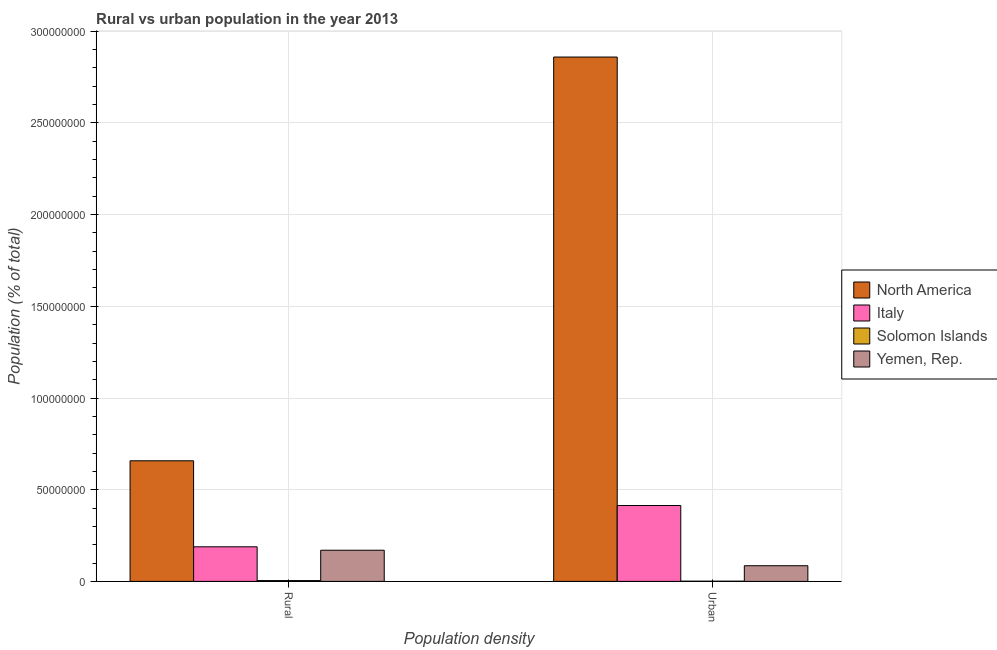How many different coloured bars are there?
Your response must be concise. 4. Are the number of bars per tick equal to the number of legend labels?
Offer a terse response. Yes. What is the label of the 1st group of bars from the left?
Your answer should be compact. Rural. What is the rural population density in Solomon Islands?
Give a very brief answer. 4.41e+05. Across all countries, what is the maximum urban population density?
Offer a terse response. 2.86e+08. Across all countries, what is the minimum urban population density?
Offer a very short reply. 1.20e+05. In which country was the urban population density maximum?
Provide a succinct answer. North America. In which country was the rural population density minimum?
Ensure brevity in your answer.  Solomon Islands. What is the total rural population density in the graph?
Offer a terse response. 1.02e+08. What is the difference between the urban population density in Italy and that in North America?
Keep it short and to the point. -2.45e+08. What is the difference between the rural population density in Solomon Islands and the urban population density in Yemen, Rep.?
Your answer should be very brief. -8.10e+06. What is the average urban population density per country?
Provide a succinct answer. 8.40e+07. What is the difference between the rural population density and urban population density in Yemen, Rep.?
Your answer should be compact. 8.45e+06. In how many countries, is the rural population density greater than 60000000 %?
Your answer should be compact. 1. What is the ratio of the rural population density in Italy to that in Solomon Islands?
Your answer should be compact. 42.81. In how many countries, is the urban population density greater than the average urban population density taken over all countries?
Give a very brief answer. 1. What does the 2nd bar from the left in Rural represents?
Your response must be concise. Italy. How many bars are there?
Give a very brief answer. 8. Are the values on the major ticks of Y-axis written in scientific E-notation?
Give a very brief answer. No. Does the graph contain any zero values?
Ensure brevity in your answer.  No. Where does the legend appear in the graph?
Keep it short and to the point. Center right. What is the title of the graph?
Ensure brevity in your answer.  Rural vs urban population in the year 2013. Does "United Arab Emirates" appear as one of the legend labels in the graph?
Your answer should be very brief. No. What is the label or title of the X-axis?
Your answer should be very brief. Population density. What is the label or title of the Y-axis?
Offer a terse response. Population (% of total). What is the Population (% of total) of North America in Rural?
Keep it short and to the point. 6.58e+07. What is the Population (% of total) in Italy in Rural?
Provide a succinct answer. 1.89e+07. What is the Population (% of total) of Solomon Islands in Rural?
Your answer should be very brief. 4.41e+05. What is the Population (% of total) of Yemen, Rep. in Rural?
Your response must be concise. 1.70e+07. What is the Population (% of total) of North America in Urban?
Offer a terse response. 2.86e+08. What is the Population (% of total) of Italy in Urban?
Make the answer very short. 4.14e+07. What is the Population (% of total) of Solomon Islands in Urban?
Ensure brevity in your answer.  1.20e+05. What is the Population (% of total) of Yemen, Rep. in Urban?
Make the answer very short. 8.54e+06. Across all Population density, what is the maximum Population (% of total) in North America?
Keep it short and to the point. 2.86e+08. Across all Population density, what is the maximum Population (% of total) of Italy?
Give a very brief answer. 4.14e+07. Across all Population density, what is the maximum Population (% of total) in Solomon Islands?
Your answer should be very brief. 4.41e+05. Across all Population density, what is the maximum Population (% of total) in Yemen, Rep.?
Make the answer very short. 1.70e+07. Across all Population density, what is the minimum Population (% of total) of North America?
Give a very brief answer. 6.58e+07. Across all Population density, what is the minimum Population (% of total) in Italy?
Your answer should be compact. 1.89e+07. Across all Population density, what is the minimum Population (% of total) of Solomon Islands?
Give a very brief answer. 1.20e+05. Across all Population density, what is the minimum Population (% of total) of Yemen, Rep.?
Provide a succinct answer. 8.54e+06. What is the total Population (% of total) of North America in the graph?
Your answer should be very brief. 3.52e+08. What is the total Population (% of total) in Italy in the graph?
Ensure brevity in your answer.  6.02e+07. What is the total Population (% of total) of Solomon Islands in the graph?
Keep it short and to the point. 5.61e+05. What is the total Population (% of total) in Yemen, Rep. in the graph?
Provide a succinct answer. 2.55e+07. What is the difference between the Population (% of total) of North America in Rural and that in Urban?
Make the answer very short. -2.20e+08. What is the difference between the Population (% of total) of Italy in Rural and that in Urban?
Your answer should be compact. -2.25e+07. What is the difference between the Population (% of total) of Solomon Islands in Rural and that in Urban?
Offer a terse response. 3.20e+05. What is the difference between the Population (% of total) of Yemen, Rep. in Rural and that in Urban?
Give a very brief answer. 8.45e+06. What is the difference between the Population (% of total) of North America in Rural and the Population (% of total) of Italy in Urban?
Give a very brief answer. 2.44e+07. What is the difference between the Population (% of total) in North America in Rural and the Population (% of total) in Solomon Islands in Urban?
Keep it short and to the point. 6.57e+07. What is the difference between the Population (% of total) in North America in Rural and the Population (% of total) in Yemen, Rep. in Urban?
Provide a succinct answer. 5.72e+07. What is the difference between the Population (% of total) in Italy in Rural and the Population (% of total) in Solomon Islands in Urban?
Keep it short and to the point. 1.87e+07. What is the difference between the Population (% of total) in Italy in Rural and the Population (% of total) in Yemen, Rep. in Urban?
Make the answer very short. 1.03e+07. What is the difference between the Population (% of total) in Solomon Islands in Rural and the Population (% of total) in Yemen, Rep. in Urban?
Ensure brevity in your answer.  -8.10e+06. What is the average Population (% of total) in North America per Population density?
Offer a terse response. 1.76e+08. What is the average Population (% of total) in Italy per Population density?
Your response must be concise. 3.01e+07. What is the average Population (% of total) in Solomon Islands per Population density?
Your response must be concise. 2.80e+05. What is the average Population (% of total) in Yemen, Rep. per Population density?
Offer a very short reply. 1.28e+07. What is the difference between the Population (% of total) of North America and Population (% of total) of Italy in Rural?
Your answer should be compact. 4.69e+07. What is the difference between the Population (% of total) in North America and Population (% of total) in Solomon Islands in Rural?
Your answer should be very brief. 6.53e+07. What is the difference between the Population (% of total) in North America and Population (% of total) in Yemen, Rep. in Rural?
Offer a very short reply. 4.88e+07. What is the difference between the Population (% of total) in Italy and Population (% of total) in Solomon Islands in Rural?
Your response must be concise. 1.84e+07. What is the difference between the Population (% of total) in Italy and Population (% of total) in Yemen, Rep. in Rural?
Give a very brief answer. 1.87e+06. What is the difference between the Population (% of total) in Solomon Islands and Population (% of total) in Yemen, Rep. in Rural?
Provide a short and direct response. -1.66e+07. What is the difference between the Population (% of total) of North America and Population (% of total) of Italy in Urban?
Your response must be concise. 2.45e+08. What is the difference between the Population (% of total) in North America and Population (% of total) in Solomon Islands in Urban?
Give a very brief answer. 2.86e+08. What is the difference between the Population (% of total) of North America and Population (% of total) of Yemen, Rep. in Urban?
Your answer should be very brief. 2.77e+08. What is the difference between the Population (% of total) in Italy and Population (% of total) in Solomon Islands in Urban?
Make the answer very short. 4.13e+07. What is the difference between the Population (% of total) in Italy and Population (% of total) in Yemen, Rep. in Urban?
Give a very brief answer. 3.28e+07. What is the difference between the Population (% of total) of Solomon Islands and Population (% of total) of Yemen, Rep. in Urban?
Your answer should be compact. -8.42e+06. What is the ratio of the Population (% of total) of North America in Rural to that in Urban?
Provide a short and direct response. 0.23. What is the ratio of the Population (% of total) of Italy in Rural to that in Urban?
Make the answer very short. 0.46. What is the ratio of the Population (% of total) of Solomon Islands in Rural to that in Urban?
Provide a short and direct response. 3.67. What is the ratio of the Population (% of total) of Yemen, Rep. in Rural to that in Urban?
Your response must be concise. 1.99. What is the difference between the highest and the second highest Population (% of total) in North America?
Make the answer very short. 2.20e+08. What is the difference between the highest and the second highest Population (% of total) of Italy?
Ensure brevity in your answer.  2.25e+07. What is the difference between the highest and the second highest Population (% of total) of Solomon Islands?
Provide a short and direct response. 3.20e+05. What is the difference between the highest and the second highest Population (% of total) of Yemen, Rep.?
Offer a terse response. 8.45e+06. What is the difference between the highest and the lowest Population (% of total) in North America?
Ensure brevity in your answer.  2.20e+08. What is the difference between the highest and the lowest Population (% of total) of Italy?
Your answer should be compact. 2.25e+07. What is the difference between the highest and the lowest Population (% of total) in Solomon Islands?
Give a very brief answer. 3.20e+05. What is the difference between the highest and the lowest Population (% of total) of Yemen, Rep.?
Provide a short and direct response. 8.45e+06. 